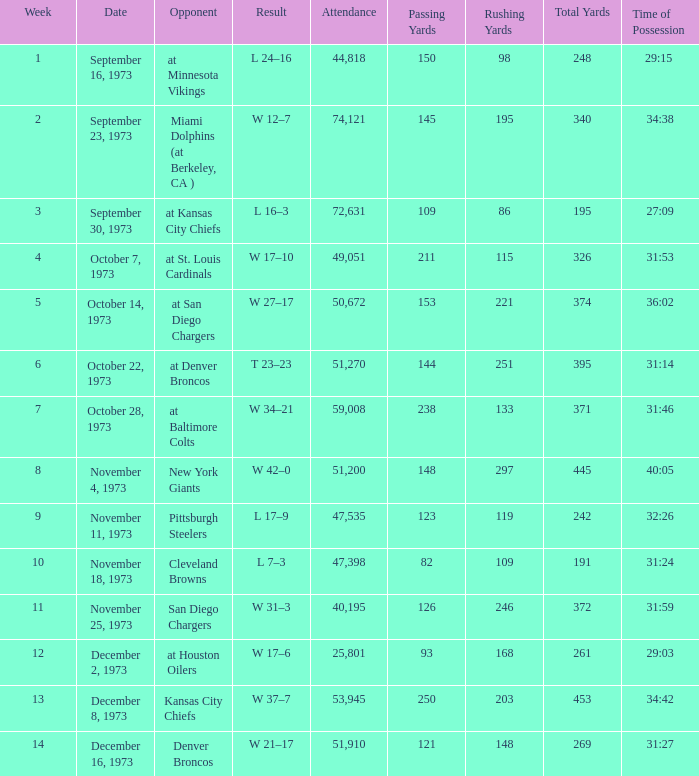What is the result later than week 13? W 21–17. 